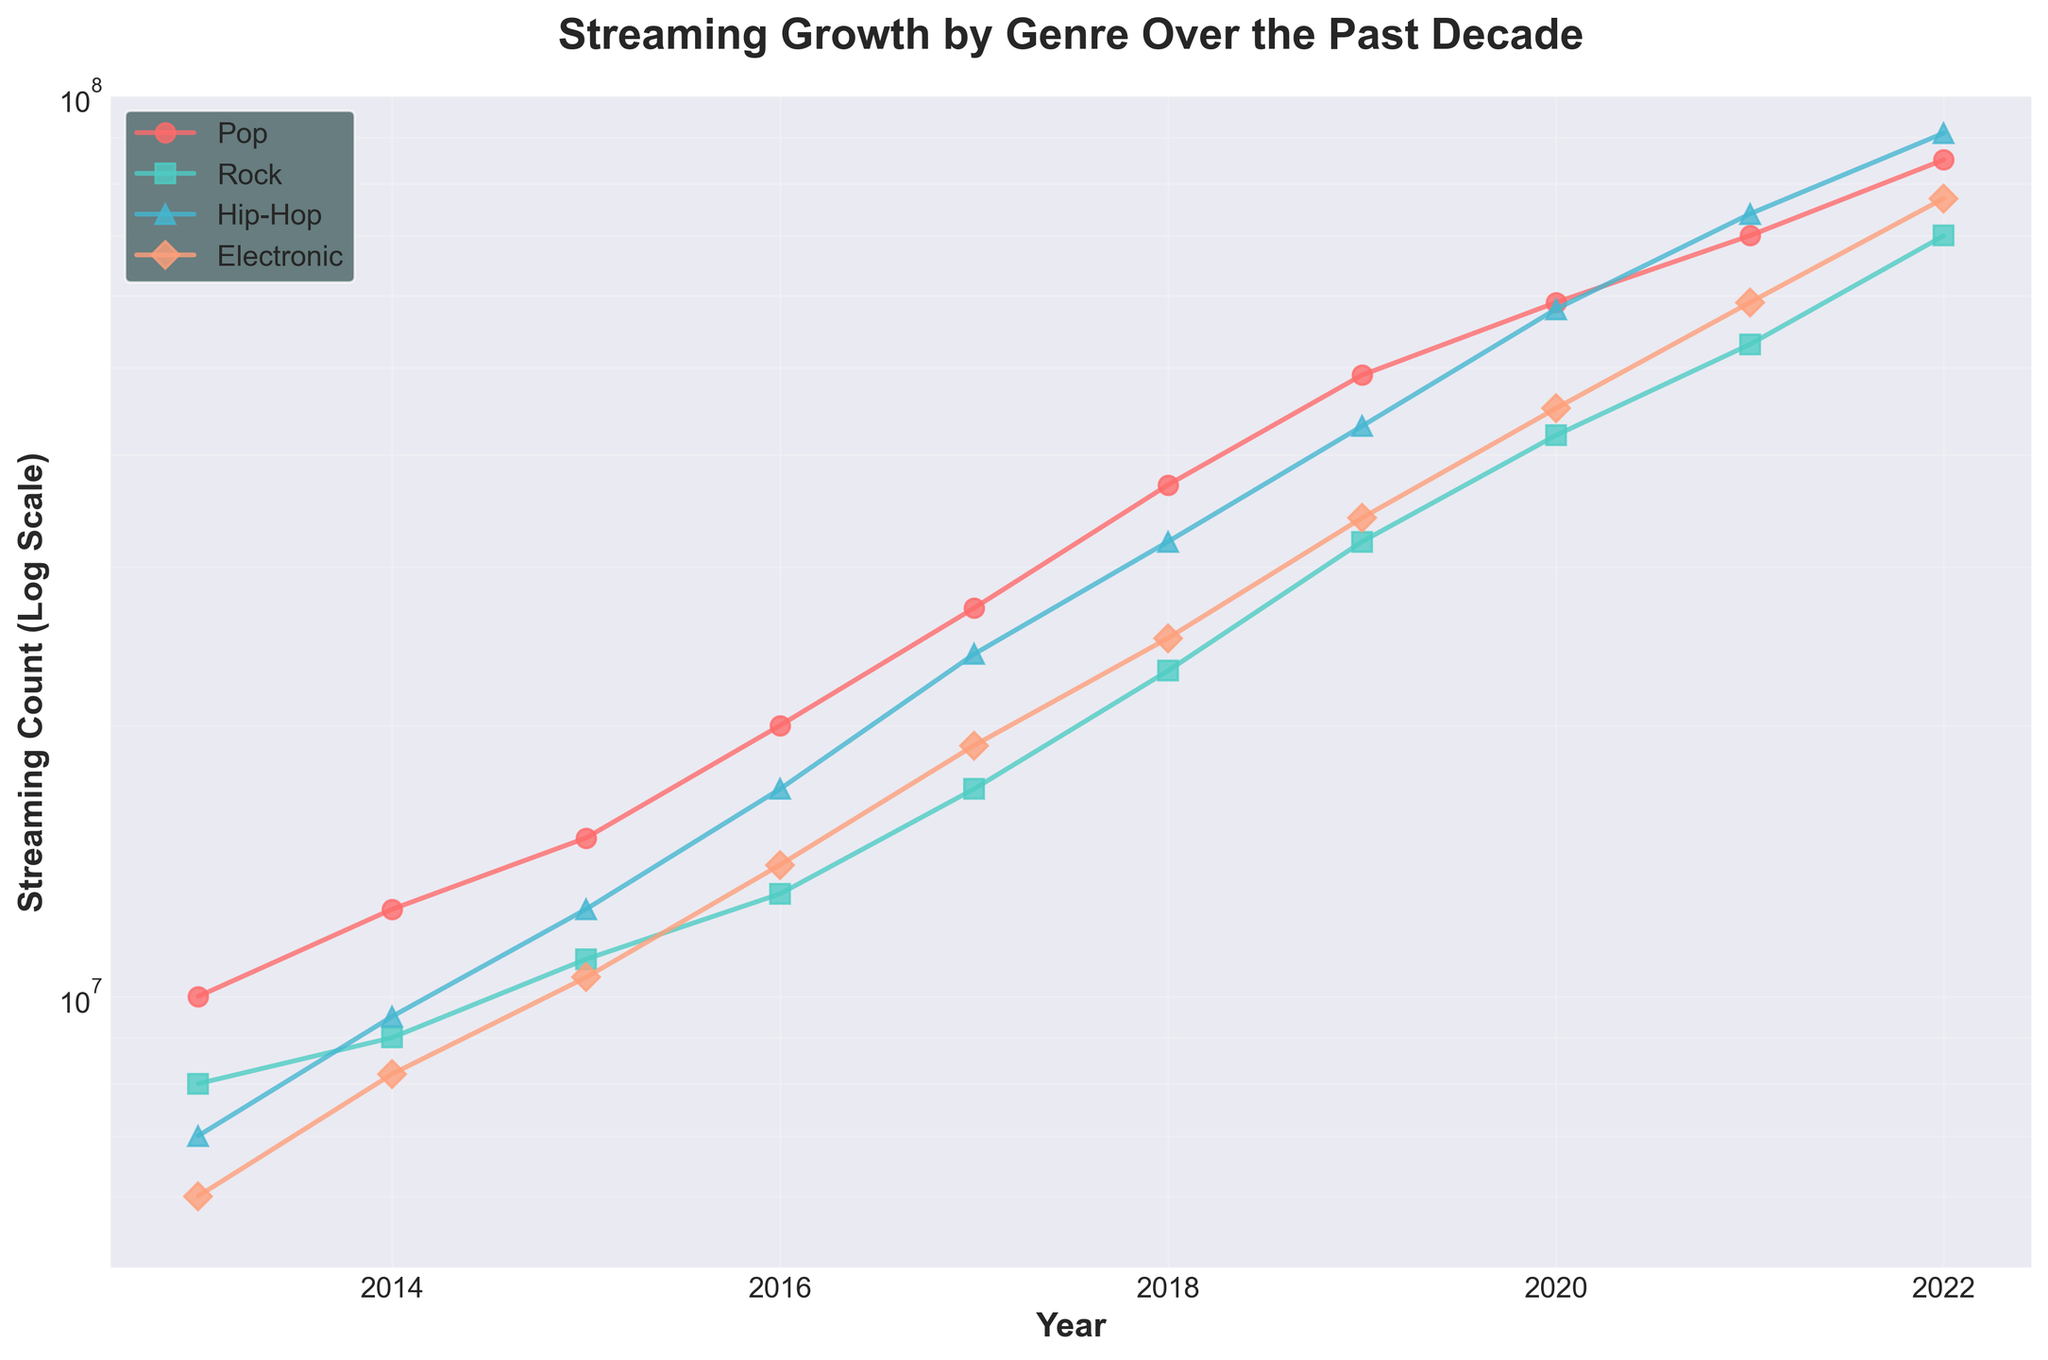What is the title of the figure? The title is located at the top of the figure, usually in a larger and bolder font to highlight the main topic of the data being presented.
Answer: Streaming Growth by Genre Over the Past Decade Which genre has the highest streaming count in 2022? By looking at the endpoints of the lines and comparing their positions on the vertical axis for the year 2022, we can identify the highest streaming count.
Answer: Hip-Hop What is the streaming count of Rock in 2017? Locate the year 2017 on the horizontal axis, follow vertically until reaching the Rock genre line, then reference the value on the vertical axis.
Answer: 17,000,000 Compare the streaming counts of Hip-Hop and Electronic in 2018. Which one is higher? Identify both points corresponding to the year 2018 for Hip-Hop and Electronic, and compare their heights on the vertical, logarithmic scale.
Answer: Hip-Hop By how much did the streaming count of Pop increase from 2013 to 2022? Subtract the streaming count of Pop in 2013 from the streaming count of Pop in 2022. The counts can be read directly from the points at these years.
Answer: 75,000,000 On average, how many streams per year did Electronic gain from 2013 to 2022? Calculate the total gain in streaming counts for Electronic from 2013 to 2022, then divide by the number of years (2022 - 2013 + 1).
Answer: 7,889,000 per year Which genre shows the steepest growth rate on the log scale throughout the decade? On a log scale, the steepest growth rate is indicated by the line with the greatest upward slope over the entire period.
Answer: Hip-Hop In which year did the streaming counts for Rock surpass 10,000,000? Find the year on the horizontal axis where the Rock line first crosses the 10,000,000 mark on the vertical axis.
Answer: 2015 Is the rate of growth for streaming counts increasing, decreasing, or consistent for the Pop genre? Assess the curvature of the Pop genre line; if the line gets steeper, the rate is increasing, if it flattens, the rate is decreasing, and if constant, the line remains linear on the logarithmic scale.
Answer: Increasing Which genre had the lowest streaming count in 2013? Inspect the starting points of all lines at the year 2013, identifying the one lowest on the vertical axis.
Answer: Electronic 